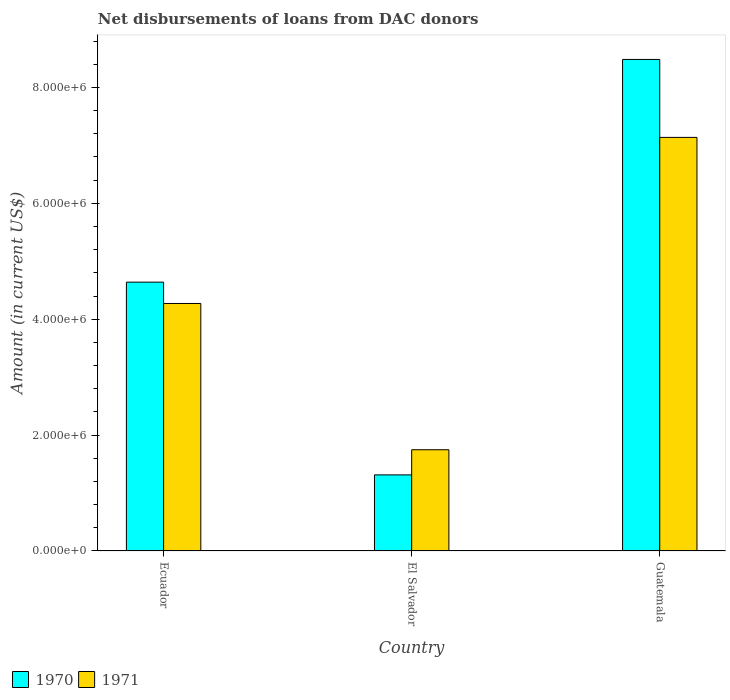How many different coloured bars are there?
Offer a terse response. 2. Are the number of bars per tick equal to the number of legend labels?
Your answer should be very brief. Yes. Are the number of bars on each tick of the X-axis equal?
Your response must be concise. Yes. How many bars are there on the 2nd tick from the left?
Provide a short and direct response. 2. How many bars are there on the 1st tick from the right?
Your answer should be very brief. 2. What is the label of the 1st group of bars from the left?
Your answer should be compact. Ecuador. What is the amount of loans disbursed in 1970 in Guatemala?
Your response must be concise. 8.48e+06. Across all countries, what is the maximum amount of loans disbursed in 1971?
Make the answer very short. 7.14e+06. Across all countries, what is the minimum amount of loans disbursed in 1971?
Provide a succinct answer. 1.75e+06. In which country was the amount of loans disbursed in 1970 maximum?
Make the answer very short. Guatemala. In which country was the amount of loans disbursed in 1970 minimum?
Your answer should be compact. El Salvador. What is the total amount of loans disbursed in 1971 in the graph?
Your response must be concise. 1.32e+07. What is the difference between the amount of loans disbursed in 1971 in Ecuador and that in El Salvador?
Your answer should be compact. 2.52e+06. What is the difference between the amount of loans disbursed in 1970 in El Salvador and the amount of loans disbursed in 1971 in Ecuador?
Your answer should be compact. -2.96e+06. What is the average amount of loans disbursed in 1970 per country?
Your answer should be very brief. 4.81e+06. What is the difference between the amount of loans disbursed of/in 1971 and amount of loans disbursed of/in 1970 in Ecuador?
Offer a terse response. -3.68e+05. What is the ratio of the amount of loans disbursed in 1970 in Ecuador to that in Guatemala?
Ensure brevity in your answer.  0.55. What is the difference between the highest and the second highest amount of loans disbursed in 1971?
Make the answer very short. 5.39e+06. What is the difference between the highest and the lowest amount of loans disbursed in 1970?
Give a very brief answer. 7.17e+06. Is the sum of the amount of loans disbursed in 1971 in El Salvador and Guatemala greater than the maximum amount of loans disbursed in 1970 across all countries?
Your answer should be compact. Yes. What does the 2nd bar from the left in Guatemala represents?
Offer a very short reply. 1971. What does the 2nd bar from the right in Guatemala represents?
Your response must be concise. 1970. How many bars are there?
Your answer should be compact. 6. Are all the bars in the graph horizontal?
Give a very brief answer. No. Are the values on the major ticks of Y-axis written in scientific E-notation?
Your answer should be compact. Yes. How are the legend labels stacked?
Offer a very short reply. Horizontal. What is the title of the graph?
Your response must be concise. Net disbursements of loans from DAC donors. What is the label or title of the X-axis?
Your answer should be very brief. Country. What is the Amount (in current US$) in 1970 in Ecuador?
Provide a short and direct response. 4.64e+06. What is the Amount (in current US$) of 1971 in Ecuador?
Offer a very short reply. 4.27e+06. What is the Amount (in current US$) of 1970 in El Salvador?
Offer a terse response. 1.31e+06. What is the Amount (in current US$) of 1971 in El Salvador?
Give a very brief answer. 1.75e+06. What is the Amount (in current US$) of 1970 in Guatemala?
Ensure brevity in your answer.  8.48e+06. What is the Amount (in current US$) of 1971 in Guatemala?
Provide a succinct answer. 7.14e+06. Across all countries, what is the maximum Amount (in current US$) of 1970?
Keep it short and to the point. 8.48e+06. Across all countries, what is the maximum Amount (in current US$) in 1971?
Provide a short and direct response. 7.14e+06. Across all countries, what is the minimum Amount (in current US$) in 1970?
Your answer should be compact. 1.31e+06. Across all countries, what is the minimum Amount (in current US$) in 1971?
Give a very brief answer. 1.75e+06. What is the total Amount (in current US$) in 1970 in the graph?
Your answer should be compact. 1.44e+07. What is the total Amount (in current US$) in 1971 in the graph?
Give a very brief answer. 1.32e+07. What is the difference between the Amount (in current US$) of 1970 in Ecuador and that in El Salvador?
Your answer should be very brief. 3.33e+06. What is the difference between the Amount (in current US$) of 1971 in Ecuador and that in El Salvador?
Your answer should be compact. 2.52e+06. What is the difference between the Amount (in current US$) in 1970 in Ecuador and that in Guatemala?
Your response must be concise. -3.84e+06. What is the difference between the Amount (in current US$) of 1971 in Ecuador and that in Guatemala?
Provide a succinct answer. -2.87e+06. What is the difference between the Amount (in current US$) in 1970 in El Salvador and that in Guatemala?
Your answer should be compact. -7.17e+06. What is the difference between the Amount (in current US$) of 1971 in El Salvador and that in Guatemala?
Ensure brevity in your answer.  -5.39e+06. What is the difference between the Amount (in current US$) in 1970 in Ecuador and the Amount (in current US$) in 1971 in El Salvador?
Your response must be concise. 2.89e+06. What is the difference between the Amount (in current US$) in 1970 in Ecuador and the Amount (in current US$) in 1971 in Guatemala?
Your response must be concise. -2.50e+06. What is the difference between the Amount (in current US$) in 1970 in El Salvador and the Amount (in current US$) in 1971 in Guatemala?
Provide a succinct answer. -5.82e+06. What is the average Amount (in current US$) of 1970 per country?
Your answer should be compact. 4.81e+06. What is the average Amount (in current US$) in 1971 per country?
Keep it short and to the point. 4.38e+06. What is the difference between the Amount (in current US$) in 1970 and Amount (in current US$) in 1971 in Ecuador?
Offer a terse response. 3.68e+05. What is the difference between the Amount (in current US$) in 1970 and Amount (in current US$) in 1971 in El Salvador?
Provide a succinct answer. -4.34e+05. What is the difference between the Amount (in current US$) in 1970 and Amount (in current US$) in 1971 in Guatemala?
Provide a short and direct response. 1.34e+06. What is the ratio of the Amount (in current US$) of 1970 in Ecuador to that in El Salvador?
Give a very brief answer. 3.53. What is the ratio of the Amount (in current US$) in 1971 in Ecuador to that in El Salvador?
Keep it short and to the point. 2.44. What is the ratio of the Amount (in current US$) in 1970 in Ecuador to that in Guatemala?
Offer a terse response. 0.55. What is the ratio of the Amount (in current US$) in 1971 in Ecuador to that in Guatemala?
Provide a short and direct response. 0.6. What is the ratio of the Amount (in current US$) of 1970 in El Salvador to that in Guatemala?
Offer a very short reply. 0.15. What is the ratio of the Amount (in current US$) of 1971 in El Salvador to that in Guatemala?
Your answer should be very brief. 0.24. What is the difference between the highest and the second highest Amount (in current US$) in 1970?
Provide a succinct answer. 3.84e+06. What is the difference between the highest and the second highest Amount (in current US$) of 1971?
Your answer should be compact. 2.87e+06. What is the difference between the highest and the lowest Amount (in current US$) of 1970?
Your response must be concise. 7.17e+06. What is the difference between the highest and the lowest Amount (in current US$) of 1971?
Offer a very short reply. 5.39e+06. 